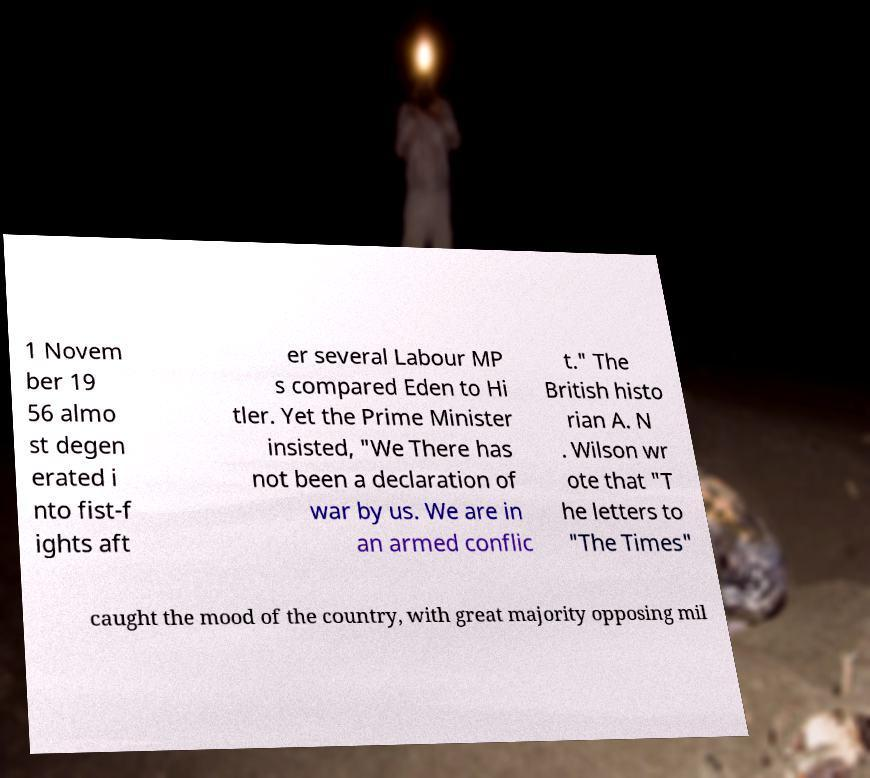Could you extract and type out the text from this image? 1 Novem ber 19 56 almo st degen erated i nto fist-f ights aft er several Labour MP s compared Eden to Hi tler. Yet the Prime Minister insisted, "We There has not been a declaration of war by us. We are in an armed conflic t." The British histo rian A. N . Wilson wr ote that "T he letters to "The Times" caught the mood of the country, with great majority opposing mil 